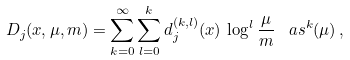<formula> <loc_0><loc_0><loc_500><loc_500>D _ { j } ( x , \mu , m ) = \sum _ { k = 0 } ^ { \infty } \sum _ { l = 0 } ^ { k } d _ { j } ^ { ( k , l ) } ( x ) \, \log ^ { l } \frac { \mu } { m } \, \ a s ^ { k } ( \mu ) \, ,</formula> 